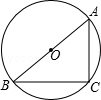If in the given figure, the chord AB passes through the center O of circle O, and point C is positioned on the circle, where angle BAC equals 52.0 degrees, what is the measure of angle ABC? Given that chord AB passes directly through the center, making it the diameter of circle O, we know that any triangle inscribed in a circle where one side is a diameter forms a right triangle. This right triangle is ABC, with the right angle at C. Therefore, the measure of angle ABC can be calculated by subtracting angle BAC from 90 degrees. Since angle BAC is 52 degrees, angle ABC is 90 - 52 = 38 degrees. Thus, the correct answer is 38 degrees, corresponding to choice B. 